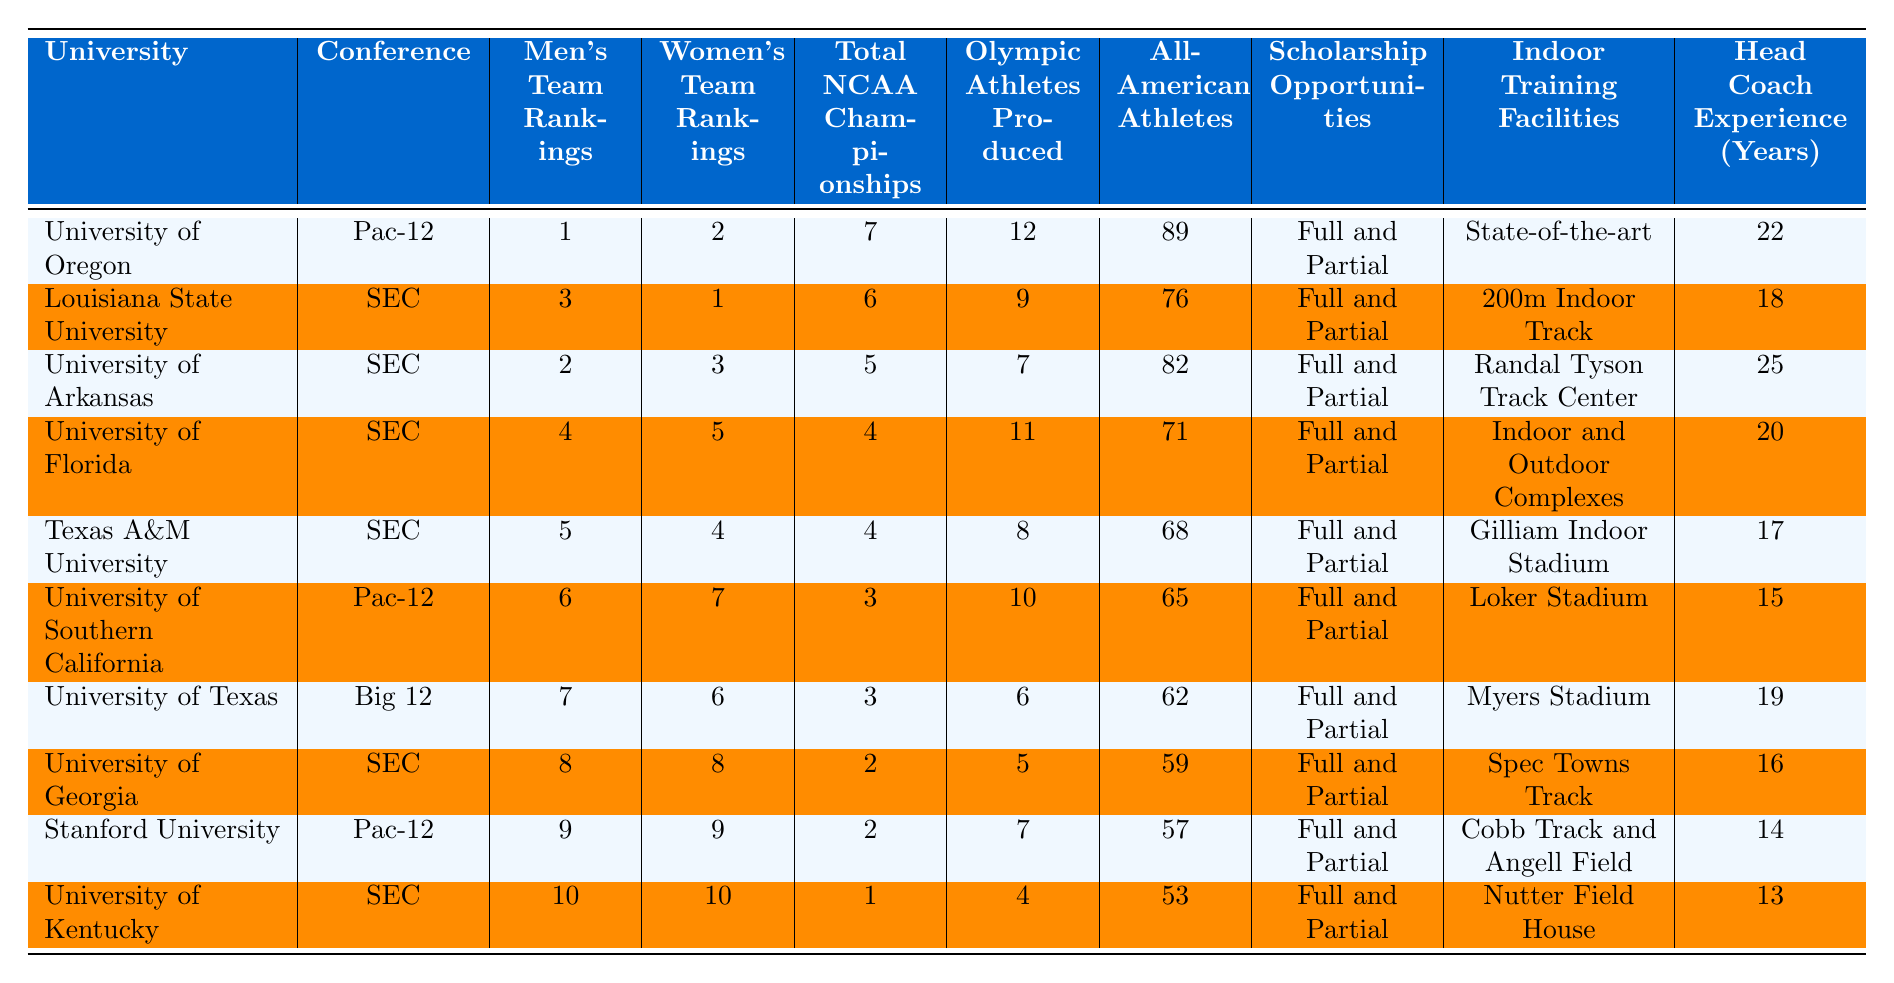What is the University with the highest Men's Team Ranking? According to the table, the University of Oregon has the highest Men's Team Ranking with a ranking of 1.
Answer: University of Oregon How many Total NCAA Championships has the University of Arkansas won? The table shows that the University of Arkansas has won a total of 5 NCAA Championships.
Answer: 5 Which university produced the most Olympic athletes? From the data, the University of Oregon produced the most Olympic athletes, totaling 12.
Answer: University of Oregon What's the average Women's Team Ranking of the top 3 programs? To find the average, we sum the Women's Team Rankings of the top 3 programs: 2 (Oregon) + 1 (LSU) + 3 (Arkansas) = 6. Then we divide by 3: 6 / 3 = 2.
Answer: 2 Which conference has the most universities listed in the top 10? The SEC has the most universities listed in the top 10, with a total of 5 schools: LSU, Arkansas, Florida, Texas A&M, and Georgia.
Answer: SEC Is it true that the University of Florida has more All-American athletes than the University of Kentucky? The University of Florida has 71 All-American athletes, while the University of Kentucky has 53. Since 71 > 53, the statement is true.
Answer: Yes Which university has the lowest Head Coach Experience among the top 10 programs? By comparing the Head Coach Experience values, the University of Kentucky has the lowest experience with 13 years.
Answer: University of Kentucky How many total NCAA Championships were won by universities in the SEC? The total is found by adding the NCAA Championships of each SEC university: 6 (LSU) + 5 (Arkansas) + 4 (Florida) + 4 (Texas A&M) + 2 (Georgia) + 1 (Kentucky) = 22 championships.
Answer: 22 Which university ranks 6th in Men's Team Rankings, and what is its location? The University of Southern California ranks 6th in Men's Team Rankings and is located in California.
Answer: University of Southern California What facilities does the University of Texas have for indoor training? The University of Texas has Myers Stadium as its indoor training facility, according to the table.
Answer: Myers Stadium Which two universities have the same Men's Team Ranking? The universities ranked 9th and 10th, Stanford University and the University of Kentucky, both have Men's Team Rankings of 9th and 10th among the top programs.
Answer: Stanford University and University of Kentucky 